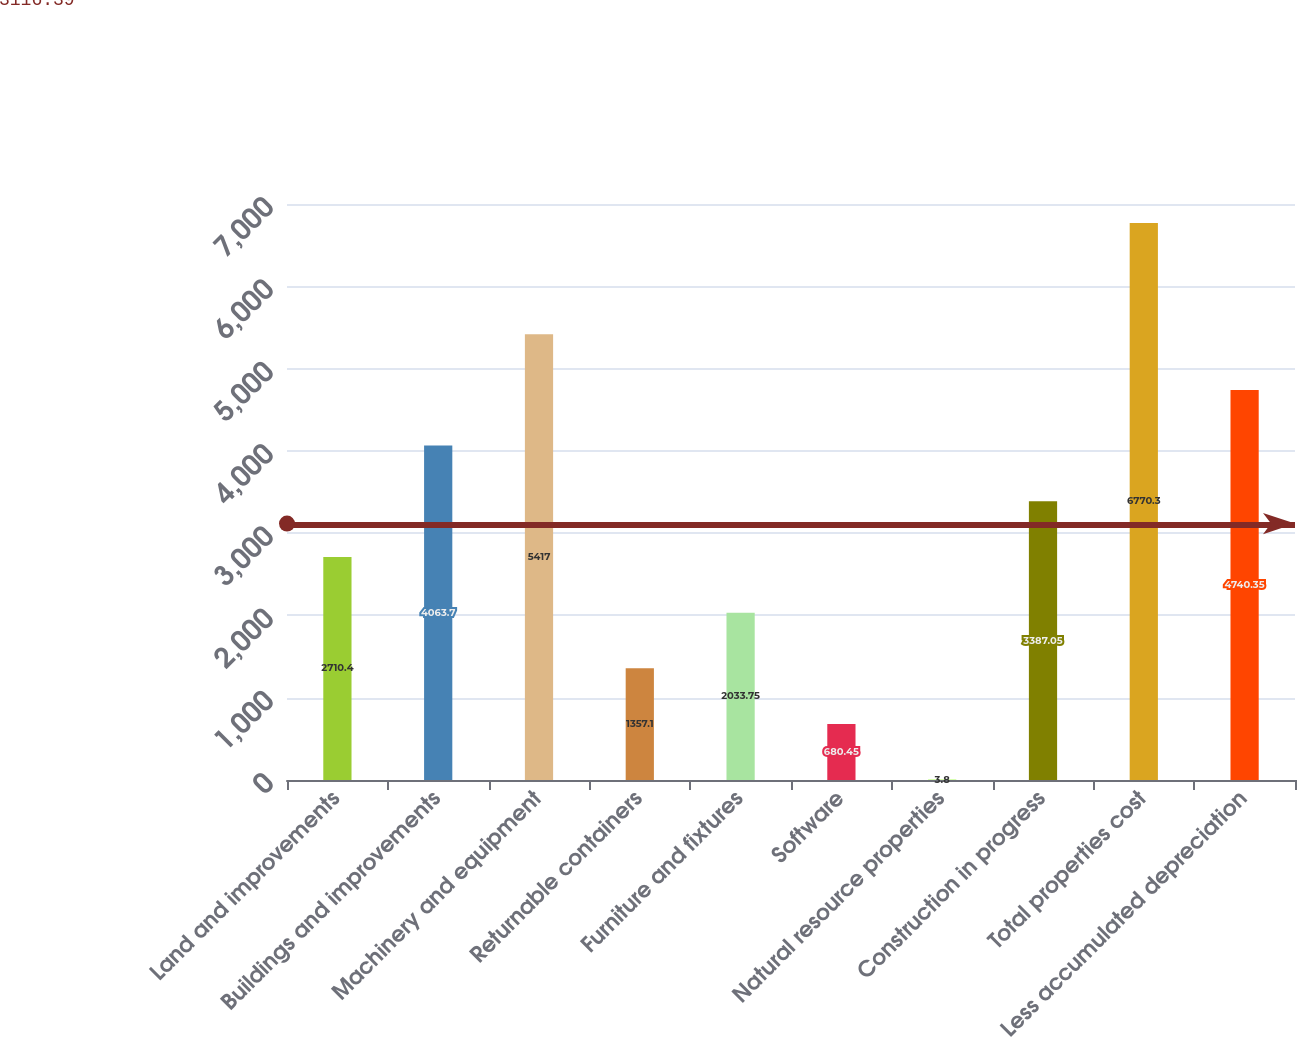Convert chart to OTSL. <chart><loc_0><loc_0><loc_500><loc_500><bar_chart><fcel>Land and improvements<fcel>Buildings and improvements<fcel>Machinery and equipment<fcel>Returnable containers<fcel>Furniture and fixtures<fcel>Software<fcel>Natural resource properties<fcel>Construction in progress<fcel>Total properties cost<fcel>Less accumulated depreciation<nl><fcel>2710.4<fcel>4063.7<fcel>5417<fcel>1357.1<fcel>2033.75<fcel>680.45<fcel>3.8<fcel>3387.05<fcel>6770.3<fcel>4740.35<nl></chart> 